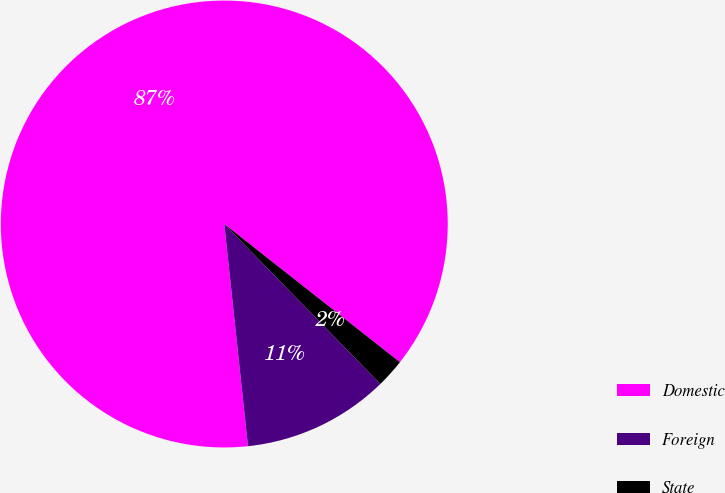Convert chart. <chart><loc_0><loc_0><loc_500><loc_500><pie_chart><fcel>Domestic<fcel>Foreign<fcel>State<nl><fcel>87.3%<fcel>10.61%<fcel>2.09%<nl></chart> 